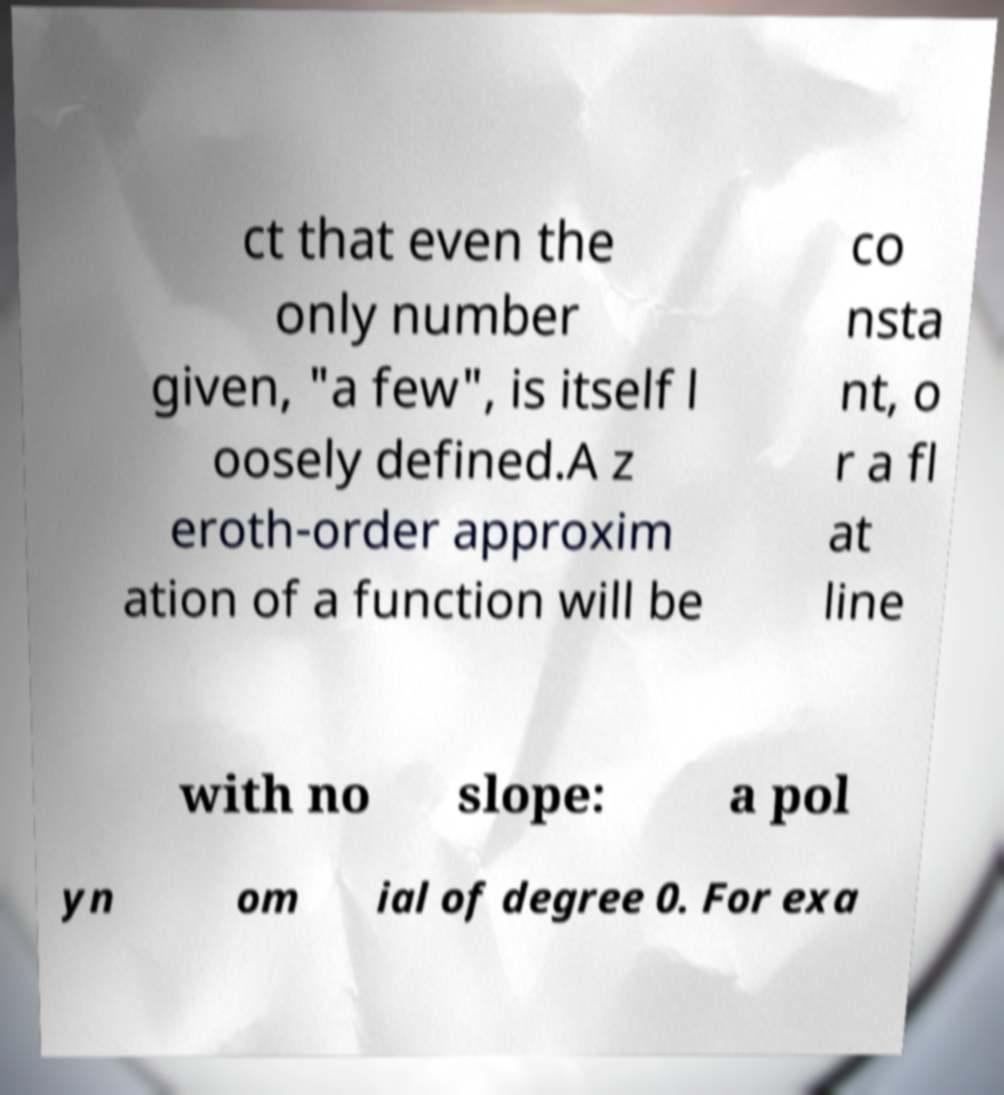Can you accurately transcribe the text from the provided image for me? ct that even the only number given, "a few", is itself l oosely defined.A z eroth-order approxim ation of a function will be co nsta nt, o r a fl at line with no slope: a pol yn om ial of degree 0. For exa 